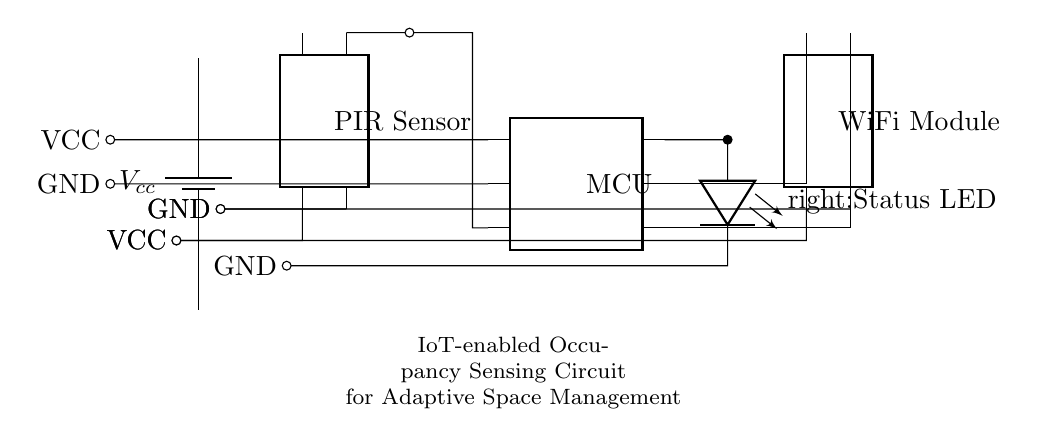What component is used for detecting occupancy? The main component for detecting occupancy in this circuit is the PIR Sensor, which stands for Passive Infrared Sensor. It is crucial for recognizing movement and occupancy in a space.
Answer: PIR Sensor What type of microcontroller is included? The circuit includes a microcontroller, referred to as MCU in the diagram, which is the central component responsible for processing the sensor data and controlling other components.
Answer: MCU How many pins does the WiFi module have? The WiFi Module in this circuit has four pins, as indicated in the diagram, which are necessary for its function and connection to the MCU.
Answer: Four What voltage does the circuit operate at? The circuit operates at a voltage of Vcc, which is typically 5V. This is the common supply voltage for many small electronic components in circuits like this one.
Answer: Vcc What is the purpose of the Status LED? The Status LED serves to indicate the operational status of the circuit, allowing users to visually determine whether the occupancy detection is active or not based on its illumination.
Answer: Status indication What are the power supply connections for the PIR sensor? The PIR sensor has two power supply connections: one for VCC, which connects to the positive voltage supply, and one for GND, which connects to ground. This is essential for its operation as it needs power to function.
Answer: VCC and GND How does the MCU interact with the WiFi module? The MCU interacts with the WiFi module through two connections: one to power the module and another to send or receive data for wireless communication. This is essential for the IoT functionality in managing space adaptive to occupancy detected.
Answer: Through two connections 